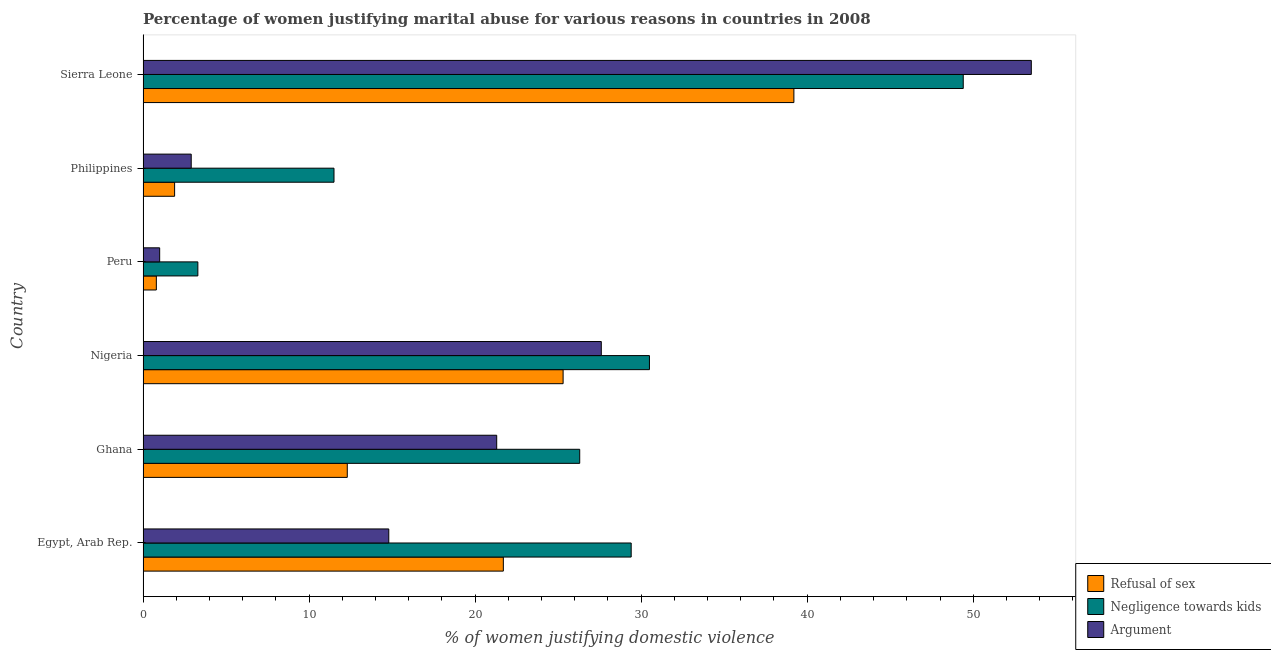How many different coloured bars are there?
Provide a succinct answer. 3. How many groups of bars are there?
Your response must be concise. 6. Are the number of bars per tick equal to the number of legend labels?
Make the answer very short. Yes. How many bars are there on the 2nd tick from the top?
Your answer should be compact. 3. What is the label of the 4th group of bars from the top?
Your answer should be compact. Nigeria. In how many cases, is the number of bars for a given country not equal to the number of legend labels?
Your answer should be compact. 0. What is the percentage of women justifying domestic violence due to refusal of sex in Sierra Leone?
Make the answer very short. 39.2. Across all countries, what is the maximum percentage of women justifying domestic violence due to negligence towards kids?
Ensure brevity in your answer.  49.4. Across all countries, what is the minimum percentage of women justifying domestic violence due to arguments?
Your answer should be very brief. 1. In which country was the percentage of women justifying domestic violence due to negligence towards kids maximum?
Your answer should be compact. Sierra Leone. What is the total percentage of women justifying domestic violence due to arguments in the graph?
Offer a terse response. 121.1. What is the difference between the percentage of women justifying domestic violence due to negligence towards kids in Egypt, Arab Rep. and that in Philippines?
Offer a very short reply. 17.9. What is the average percentage of women justifying domestic violence due to negligence towards kids per country?
Your response must be concise. 25.07. What is the ratio of the percentage of women justifying domestic violence due to negligence towards kids in Peru to that in Philippines?
Your answer should be very brief. 0.29. Is the percentage of women justifying domestic violence due to negligence towards kids in Egypt, Arab Rep. less than that in Peru?
Offer a terse response. No. What is the difference between the highest and the lowest percentage of women justifying domestic violence due to refusal of sex?
Ensure brevity in your answer.  38.4. In how many countries, is the percentage of women justifying domestic violence due to refusal of sex greater than the average percentage of women justifying domestic violence due to refusal of sex taken over all countries?
Keep it short and to the point. 3. What does the 1st bar from the top in Nigeria represents?
Your response must be concise. Argument. What does the 1st bar from the bottom in Philippines represents?
Offer a terse response. Refusal of sex. Is it the case that in every country, the sum of the percentage of women justifying domestic violence due to refusal of sex and percentage of women justifying domestic violence due to negligence towards kids is greater than the percentage of women justifying domestic violence due to arguments?
Provide a succinct answer. Yes. What is the difference between two consecutive major ticks on the X-axis?
Provide a succinct answer. 10. Are the values on the major ticks of X-axis written in scientific E-notation?
Provide a short and direct response. No. Does the graph contain any zero values?
Give a very brief answer. No. Does the graph contain grids?
Offer a very short reply. No. Where does the legend appear in the graph?
Keep it short and to the point. Bottom right. What is the title of the graph?
Provide a short and direct response. Percentage of women justifying marital abuse for various reasons in countries in 2008. Does "Negligence towards kids" appear as one of the legend labels in the graph?
Keep it short and to the point. Yes. What is the label or title of the X-axis?
Provide a short and direct response. % of women justifying domestic violence. What is the label or title of the Y-axis?
Offer a terse response. Country. What is the % of women justifying domestic violence of Refusal of sex in Egypt, Arab Rep.?
Offer a terse response. 21.7. What is the % of women justifying domestic violence in Negligence towards kids in Egypt, Arab Rep.?
Your answer should be compact. 29.4. What is the % of women justifying domestic violence of Argument in Egypt, Arab Rep.?
Provide a succinct answer. 14.8. What is the % of women justifying domestic violence of Negligence towards kids in Ghana?
Your answer should be very brief. 26.3. What is the % of women justifying domestic violence in Argument in Ghana?
Your response must be concise. 21.3. What is the % of women justifying domestic violence of Refusal of sex in Nigeria?
Offer a terse response. 25.3. What is the % of women justifying domestic violence of Negligence towards kids in Nigeria?
Your answer should be compact. 30.5. What is the % of women justifying domestic violence in Argument in Nigeria?
Make the answer very short. 27.6. What is the % of women justifying domestic violence of Refusal of sex in Peru?
Provide a short and direct response. 0.8. What is the % of women justifying domestic violence in Negligence towards kids in Peru?
Offer a very short reply. 3.3. What is the % of women justifying domestic violence of Argument in Philippines?
Give a very brief answer. 2.9. What is the % of women justifying domestic violence in Refusal of sex in Sierra Leone?
Give a very brief answer. 39.2. What is the % of women justifying domestic violence in Negligence towards kids in Sierra Leone?
Provide a short and direct response. 49.4. What is the % of women justifying domestic violence in Argument in Sierra Leone?
Your answer should be compact. 53.5. Across all countries, what is the maximum % of women justifying domestic violence in Refusal of sex?
Provide a short and direct response. 39.2. Across all countries, what is the maximum % of women justifying domestic violence in Negligence towards kids?
Provide a succinct answer. 49.4. Across all countries, what is the maximum % of women justifying domestic violence in Argument?
Ensure brevity in your answer.  53.5. Across all countries, what is the minimum % of women justifying domestic violence in Refusal of sex?
Your response must be concise. 0.8. Across all countries, what is the minimum % of women justifying domestic violence in Negligence towards kids?
Make the answer very short. 3.3. What is the total % of women justifying domestic violence of Refusal of sex in the graph?
Provide a succinct answer. 101.2. What is the total % of women justifying domestic violence in Negligence towards kids in the graph?
Offer a terse response. 150.4. What is the total % of women justifying domestic violence of Argument in the graph?
Provide a short and direct response. 121.1. What is the difference between the % of women justifying domestic violence of Refusal of sex in Egypt, Arab Rep. and that in Ghana?
Make the answer very short. 9.4. What is the difference between the % of women justifying domestic violence in Negligence towards kids in Egypt, Arab Rep. and that in Ghana?
Provide a short and direct response. 3.1. What is the difference between the % of women justifying domestic violence of Argument in Egypt, Arab Rep. and that in Nigeria?
Your answer should be very brief. -12.8. What is the difference between the % of women justifying domestic violence in Refusal of sex in Egypt, Arab Rep. and that in Peru?
Your response must be concise. 20.9. What is the difference between the % of women justifying domestic violence of Negligence towards kids in Egypt, Arab Rep. and that in Peru?
Offer a terse response. 26.1. What is the difference between the % of women justifying domestic violence in Argument in Egypt, Arab Rep. and that in Peru?
Offer a terse response. 13.8. What is the difference between the % of women justifying domestic violence of Refusal of sex in Egypt, Arab Rep. and that in Philippines?
Your answer should be very brief. 19.8. What is the difference between the % of women justifying domestic violence of Refusal of sex in Egypt, Arab Rep. and that in Sierra Leone?
Your answer should be compact. -17.5. What is the difference between the % of women justifying domestic violence of Negligence towards kids in Egypt, Arab Rep. and that in Sierra Leone?
Your answer should be very brief. -20. What is the difference between the % of women justifying domestic violence of Argument in Egypt, Arab Rep. and that in Sierra Leone?
Offer a very short reply. -38.7. What is the difference between the % of women justifying domestic violence in Refusal of sex in Ghana and that in Nigeria?
Give a very brief answer. -13. What is the difference between the % of women justifying domestic violence in Negligence towards kids in Ghana and that in Nigeria?
Your answer should be very brief. -4.2. What is the difference between the % of women justifying domestic violence of Argument in Ghana and that in Nigeria?
Offer a terse response. -6.3. What is the difference between the % of women justifying domestic violence of Argument in Ghana and that in Peru?
Give a very brief answer. 20.3. What is the difference between the % of women justifying domestic violence in Negligence towards kids in Ghana and that in Philippines?
Provide a short and direct response. 14.8. What is the difference between the % of women justifying domestic violence in Refusal of sex in Ghana and that in Sierra Leone?
Your response must be concise. -26.9. What is the difference between the % of women justifying domestic violence in Negligence towards kids in Ghana and that in Sierra Leone?
Your answer should be very brief. -23.1. What is the difference between the % of women justifying domestic violence of Argument in Ghana and that in Sierra Leone?
Your answer should be very brief. -32.2. What is the difference between the % of women justifying domestic violence of Refusal of sex in Nigeria and that in Peru?
Your answer should be compact. 24.5. What is the difference between the % of women justifying domestic violence of Negligence towards kids in Nigeria and that in Peru?
Give a very brief answer. 27.2. What is the difference between the % of women justifying domestic violence of Argument in Nigeria and that in Peru?
Offer a terse response. 26.6. What is the difference between the % of women justifying domestic violence in Refusal of sex in Nigeria and that in Philippines?
Offer a very short reply. 23.4. What is the difference between the % of women justifying domestic violence of Negligence towards kids in Nigeria and that in Philippines?
Provide a succinct answer. 19. What is the difference between the % of women justifying domestic violence of Argument in Nigeria and that in Philippines?
Make the answer very short. 24.7. What is the difference between the % of women justifying domestic violence in Negligence towards kids in Nigeria and that in Sierra Leone?
Offer a very short reply. -18.9. What is the difference between the % of women justifying domestic violence of Argument in Nigeria and that in Sierra Leone?
Provide a short and direct response. -25.9. What is the difference between the % of women justifying domestic violence in Refusal of sex in Peru and that in Philippines?
Make the answer very short. -1.1. What is the difference between the % of women justifying domestic violence of Refusal of sex in Peru and that in Sierra Leone?
Give a very brief answer. -38.4. What is the difference between the % of women justifying domestic violence of Negligence towards kids in Peru and that in Sierra Leone?
Offer a very short reply. -46.1. What is the difference between the % of women justifying domestic violence in Argument in Peru and that in Sierra Leone?
Offer a very short reply. -52.5. What is the difference between the % of women justifying domestic violence in Refusal of sex in Philippines and that in Sierra Leone?
Provide a succinct answer. -37.3. What is the difference between the % of women justifying domestic violence of Negligence towards kids in Philippines and that in Sierra Leone?
Give a very brief answer. -37.9. What is the difference between the % of women justifying domestic violence in Argument in Philippines and that in Sierra Leone?
Keep it short and to the point. -50.6. What is the difference between the % of women justifying domestic violence in Refusal of sex in Egypt, Arab Rep. and the % of women justifying domestic violence in Negligence towards kids in Ghana?
Make the answer very short. -4.6. What is the difference between the % of women justifying domestic violence in Refusal of sex in Egypt, Arab Rep. and the % of women justifying domestic violence in Argument in Peru?
Your response must be concise. 20.7. What is the difference between the % of women justifying domestic violence in Negligence towards kids in Egypt, Arab Rep. and the % of women justifying domestic violence in Argument in Peru?
Your answer should be very brief. 28.4. What is the difference between the % of women justifying domestic violence in Negligence towards kids in Egypt, Arab Rep. and the % of women justifying domestic violence in Argument in Philippines?
Your response must be concise. 26.5. What is the difference between the % of women justifying domestic violence of Refusal of sex in Egypt, Arab Rep. and the % of women justifying domestic violence of Negligence towards kids in Sierra Leone?
Your answer should be very brief. -27.7. What is the difference between the % of women justifying domestic violence in Refusal of sex in Egypt, Arab Rep. and the % of women justifying domestic violence in Argument in Sierra Leone?
Give a very brief answer. -31.8. What is the difference between the % of women justifying domestic violence in Negligence towards kids in Egypt, Arab Rep. and the % of women justifying domestic violence in Argument in Sierra Leone?
Your answer should be very brief. -24.1. What is the difference between the % of women justifying domestic violence of Refusal of sex in Ghana and the % of women justifying domestic violence of Negligence towards kids in Nigeria?
Make the answer very short. -18.2. What is the difference between the % of women justifying domestic violence of Refusal of sex in Ghana and the % of women justifying domestic violence of Argument in Nigeria?
Make the answer very short. -15.3. What is the difference between the % of women justifying domestic violence of Refusal of sex in Ghana and the % of women justifying domestic violence of Negligence towards kids in Peru?
Offer a very short reply. 9. What is the difference between the % of women justifying domestic violence in Refusal of sex in Ghana and the % of women justifying domestic violence in Argument in Peru?
Provide a succinct answer. 11.3. What is the difference between the % of women justifying domestic violence in Negligence towards kids in Ghana and the % of women justifying domestic violence in Argument in Peru?
Provide a succinct answer. 25.3. What is the difference between the % of women justifying domestic violence in Refusal of sex in Ghana and the % of women justifying domestic violence in Negligence towards kids in Philippines?
Offer a very short reply. 0.8. What is the difference between the % of women justifying domestic violence of Refusal of sex in Ghana and the % of women justifying domestic violence of Argument in Philippines?
Give a very brief answer. 9.4. What is the difference between the % of women justifying domestic violence in Negligence towards kids in Ghana and the % of women justifying domestic violence in Argument in Philippines?
Keep it short and to the point. 23.4. What is the difference between the % of women justifying domestic violence in Refusal of sex in Ghana and the % of women justifying domestic violence in Negligence towards kids in Sierra Leone?
Your answer should be very brief. -37.1. What is the difference between the % of women justifying domestic violence in Refusal of sex in Ghana and the % of women justifying domestic violence in Argument in Sierra Leone?
Your answer should be very brief. -41.2. What is the difference between the % of women justifying domestic violence of Negligence towards kids in Ghana and the % of women justifying domestic violence of Argument in Sierra Leone?
Your response must be concise. -27.2. What is the difference between the % of women justifying domestic violence of Refusal of sex in Nigeria and the % of women justifying domestic violence of Negligence towards kids in Peru?
Your response must be concise. 22. What is the difference between the % of women justifying domestic violence of Refusal of sex in Nigeria and the % of women justifying domestic violence of Argument in Peru?
Offer a terse response. 24.3. What is the difference between the % of women justifying domestic violence of Negligence towards kids in Nigeria and the % of women justifying domestic violence of Argument in Peru?
Give a very brief answer. 29.5. What is the difference between the % of women justifying domestic violence of Refusal of sex in Nigeria and the % of women justifying domestic violence of Argument in Philippines?
Provide a short and direct response. 22.4. What is the difference between the % of women justifying domestic violence in Negligence towards kids in Nigeria and the % of women justifying domestic violence in Argument in Philippines?
Keep it short and to the point. 27.6. What is the difference between the % of women justifying domestic violence of Refusal of sex in Nigeria and the % of women justifying domestic violence of Negligence towards kids in Sierra Leone?
Provide a short and direct response. -24.1. What is the difference between the % of women justifying domestic violence of Refusal of sex in Nigeria and the % of women justifying domestic violence of Argument in Sierra Leone?
Ensure brevity in your answer.  -28.2. What is the difference between the % of women justifying domestic violence of Negligence towards kids in Nigeria and the % of women justifying domestic violence of Argument in Sierra Leone?
Offer a terse response. -23. What is the difference between the % of women justifying domestic violence of Refusal of sex in Peru and the % of women justifying domestic violence of Negligence towards kids in Philippines?
Keep it short and to the point. -10.7. What is the difference between the % of women justifying domestic violence in Negligence towards kids in Peru and the % of women justifying domestic violence in Argument in Philippines?
Provide a succinct answer. 0.4. What is the difference between the % of women justifying domestic violence in Refusal of sex in Peru and the % of women justifying domestic violence in Negligence towards kids in Sierra Leone?
Ensure brevity in your answer.  -48.6. What is the difference between the % of women justifying domestic violence in Refusal of sex in Peru and the % of women justifying domestic violence in Argument in Sierra Leone?
Keep it short and to the point. -52.7. What is the difference between the % of women justifying domestic violence in Negligence towards kids in Peru and the % of women justifying domestic violence in Argument in Sierra Leone?
Provide a succinct answer. -50.2. What is the difference between the % of women justifying domestic violence in Refusal of sex in Philippines and the % of women justifying domestic violence in Negligence towards kids in Sierra Leone?
Your response must be concise. -47.5. What is the difference between the % of women justifying domestic violence of Refusal of sex in Philippines and the % of women justifying domestic violence of Argument in Sierra Leone?
Keep it short and to the point. -51.6. What is the difference between the % of women justifying domestic violence of Negligence towards kids in Philippines and the % of women justifying domestic violence of Argument in Sierra Leone?
Your answer should be compact. -42. What is the average % of women justifying domestic violence in Refusal of sex per country?
Your response must be concise. 16.87. What is the average % of women justifying domestic violence of Negligence towards kids per country?
Your answer should be very brief. 25.07. What is the average % of women justifying domestic violence in Argument per country?
Offer a terse response. 20.18. What is the difference between the % of women justifying domestic violence of Refusal of sex and % of women justifying domestic violence of Argument in Egypt, Arab Rep.?
Provide a short and direct response. 6.9. What is the difference between the % of women justifying domestic violence in Negligence towards kids and % of women justifying domestic violence in Argument in Egypt, Arab Rep.?
Offer a terse response. 14.6. What is the difference between the % of women justifying domestic violence of Refusal of sex and % of women justifying domestic violence of Argument in Ghana?
Provide a short and direct response. -9. What is the difference between the % of women justifying domestic violence in Negligence towards kids and % of women justifying domestic violence in Argument in Ghana?
Make the answer very short. 5. What is the difference between the % of women justifying domestic violence of Refusal of sex and % of women justifying domestic violence of Argument in Nigeria?
Your response must be concise. -2.3. What is the difference between the % of women justifying domestic violence of Negligence towards kids and % of women justifying domestic violence of Argument in Nigeria?
Offer a very short reply. 2.9. What is the difference between the % of women justifying domestic violence of Refusal of sex and % of women justifying domestic violence of Negligence towards kids in Peru?
Keep it short and to the point. -2.5. What is the difference between the % of women justifying domestic violence of Refusal of sex and % of women justifying domestic violence of Argument in Peru?
Provide a succinct answer. -0.2. What is the difference between the % of women justifying domestic violence in Negligence towards kids and % of women justifying domestic violence in Argument in Peru?
Your answer should be very brief. 2.3. What is the difference between the % of women justifying domestic violence of Refusal of sex and % of women justifying domestic violence of Negligence towards kids in Philippines?
Ensure brevity in your answer.  -9.6. What is the difference between the % of women justifying domestic violence in Refusal of sex and % of women justifying domestic violence in Argument in Philippines?
Your response must be concise. -1. What is the difference between the % of women justifying domestic violence in Negligence towards kids and % of women justifying domestic violence in Argument in Philippines?
Offer a very short reply. 8.6. What is the difference between the % of women justifying domestic violence in Refusal of sex and % of women justifying domestic violence in Argument in Sierra Leone?
Offer a terse response. -14.3. What is the difference between the % of women justifying domestic violence of Negligence towards kids and % of women justifying domestic violence of Argument in Sierra Leone?
Make the answer very short. -4.1. What is the ratio of the % of women justifying domestic violence of Refusal of sex in Egypt, Arab Rep. to that in Ghana?
Keep it short and to the point. 1.76. What is the ratio of the % of women justifying domestic violence of Negligence towards kids in Egypt, Arab Rep. to that in Ghana?
Keep it short and to the point. 1.12. What is the ratio of the % of women justifying domestic violence of Argument in Egypt, Arab Rep. to that in Ghana?
Your answer should be very brief. 0.69. What is the ratio of the % of women justifying domestic violence in Refusal of sex in Egypt, Arab Rep. to that in Nigeria?
Provide a succinct answer. 0.86. What is the ratio of the % of women justifying domestic violence in Negligence towards kids in Egypt, Arab Rep. to that in Nigeria?
Your answer should be compact. 0.96. What is the ratio of the % of women justifying domestic violence of Argument in Egypt, Arab Rep. to that in Nigeria?
Your response must be concise. 0.54. What is the ratio of the % of women justifying domestic violence of Refusal of sex in Egypt, Arab Rep. to that in Peru?
Provide a short and direct response. 27.12. What is the ratio of the % of women justifying domestic violence in Negligence towards kids in Egypt, Arab Rep. to that in Peru?
Make the answer very short. 8.91. What is the ratio of the % of women justifying domestic violence in Refusal of sex in Egypt, Arab Rep. to that in Philippines?
Offer a terse response. 11.42. What is the ratio of the % of women justifying domestic violence in Negligence towards kids in Egypt, Arab Rep. to that in Philippines?
Your answer should be compact. 2.56. What is the ratio of the % of women justifying domestic violence of Argument in Egypt, Arab Rep. to that in Philippines?
Your answer should be very brief. 5.1. What is the ratio of the % of women justifying domestic violence in Refusal of sex in Egypt, Arab Rep. to that in Sierra Leone?
Provide a short and direct response. 0.55. What is the ratio of the % of women justifying domestic violence of Negligence towards kids in Egypt, Arab Rep. to that in Sierra Leone?
Provide a succinct answer. 0.6. What is the ratio of the % of women justifying domestic violence in Argument in Egypt, Arab Rep. to that in Sierra Leone?
Provide a succinct answer. 0.28. What is the ratio of the % of women justifying domestic violence of Refusal of sex in Ghana to that in Nigeria?
Keep it short and to the point. 0.49. What is the ratio of the % of women justifying domestic violence of Negligence towards kids in Ghana to that in Nigeria?
Offer a very short reply. 0.86. What is the ratio of the % of women justifying domestic violence of Argument in Ghana to that in Nigeria?
Give a very brief answer. 0.77. What is the ratio of the % of women justifying domestic violence of Refusal of sex in Ghana to that in Peru?
Offer a very short reply. 15.38. What is the ratio of the % of women justifying domestic violence of Negligence towards kids in Ghana to that in Peru?
Provide a succinct answer. 7.97. What is the ratio of the % of women justifying domestic violence in Argument in Ghana to that in Peru?
Keep it short and to the point. 21.3. What is the ratio of the % of women justifying domestic violence in Refusal of sex in Ghana to that in Philippines?
Offer a very short reply. 6.47. What is the ratio of the % of women justifying domestic violence in Negligence towards kids in Ghana to that in Philippines?
Provide a succinct answer. 2.29. What is the ratio of the % of women justifying domestic violence of Argument in Ghana to that in Philippines?
Offer a terse response. 7.34. What is the ratio of the % of women justifying domestic violence in Refusal of sex in Ghana to that in Sierra Leone?
Offer a very short reply. 0.31. What is the ratio of the % of women justifying domestic violence in Negligence towards kids in Ghana to that in Sierra Leone?
Your answer should be very brief. 0.53. What is the ratio of the % of women justifying domestic violence of Argument in Ghana to that in Sierra Leone?
Your answer should be very brief. 0.4. What is the ratio of the % of women justifying domestic violence of Refusal of sex in Nigeria to that in Peru?
Ensure brevity in your answer.  31.62. What is the ratio of the % of women justifying domestic violence of Negligence towards kids in Nigeria to that in Peru?
Keep it short and to the point. 9.24. What is the ratio of the % of women justifying domestic violence in Argument in Nigeria to that in Peru?
Ensure brevity in your answer.  27.6. What is the ratio of the % of women justifying domestic violence of Refusal of sex in Nigeria to that in Philippines?
Your answer should be compact. 13.32. What is the ratio of the % of women justifying domestic violence of Negligence towards kids in Nigeria to that in Philippines?
Your response must be concise. 2.65. What is the ratio of the % of women justifying domestic violence in Argument in Nigeria to that in Philippines?
Provide a succinct answer. 9.52. What is the ratio of the % of women justifying domestic violence in Refusal of sex in Nigeria to that in Sierra Leone?
Offer a terse response. 0.65. What is the ratio of the % of women justifying domestic violence in Negligence towards kids in Nigeria to that in Sierra Leone?
Give a very brief answer. 0.62. What is the ratio of the % of women justifying domestic violence of Argument in Nigeria to that in Sierra Leone?
Offer a very short reply. 0.52. What is the ratio of the % of women justifying domestic violence in Refusal of sex in Peru to that in Philippines?
Provide a short and direct response. 0.42. What is the ratio of the % of women justifying domestic violence in Negligence towards kids in Peru to that in Philippines?
Offer a very short reply. 0.29. What is the ratio of the % of women justifying domestic violence of Argument in Peru to that in Philippines?
Offer a very short reply. 0.34. What is the ratio of the % of women justifying domestic violence in Refusal of sex in Peru to that in Sierra Leone?
Ensure brevity in your answer.  0.02. What is the ratio of the % of women justifying domestic violence in Negligence towards kids in Peru to that in Sierra Leone?
Give a very brief answer. 0.07. What is the ratio of the % of women justifying domestic violence of Argument in Peru to that in Sierra Leone?
Provide a succinct answer. 0.02. What is the ratio of the % of women justifying domestic violence of Refusal of sex in Philippines to that in Sierra Leone?
Give a very brief answer. 0.05. What is the ratio of the % of women justifying domestic violence of Negligence towards kids in Philippines to that in Sierra Leone?
Offer a very short reply. 0.23. What is the ratio of the % of women justifying domestic violence of Argument in Philippines to that in Sierra Leone?
Your answer should be very brief. 0.05. What is the difference between the highest and the second highest % of women justifying domestic violence of Negligence towards kids?
Make the answer very short. 18.9. What is the difference between the highest and the second highest % of women justifying domestic violence in Argument?
Make the answer very short. 25.9. What is the difference between the highest and the lowest % of women justifying domestic violence of Refusal of sex?
Your answer should be very brief. 38.4. What is the difference between the highest and the lowest % of women justifying domestic violence of Negligence towards kids?
Your answer should be very brief. 46.1. What is the difference between the highest and the lowest % of women justifying domestic violence of Argument?
Offer a terse response. 52.5. 